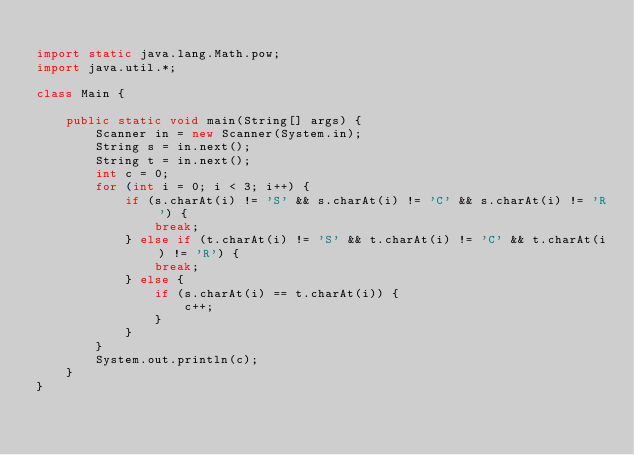<code> <loc_0><loc_0><loc_500><loc_500><_Java_>
import static java.lang.Math.pow;
import java.util.*;

class Main {

    public static void main(String[] args) {
        Scanner in = new Scanner(System.in);
        String s = in.next();
        String t = in.next();
        int c = 0;
        for (int i = 0; i < 3; i++) {
            if (s.charAt(i) != 'S' && s.charAt(i) != 'C' && s.charAt(i) != 'R') {
                break;
            } else if (t.charAt(i) != 'S' && t.charAt(i) != 'C' && t.charAt(i) != 'R') {
                break;
            } else {
                if (s.charAt(i) == t.charAt(i)) {
                    c++;
                }
            }
        }
        System.out.println(c);
    }
}
</code> 